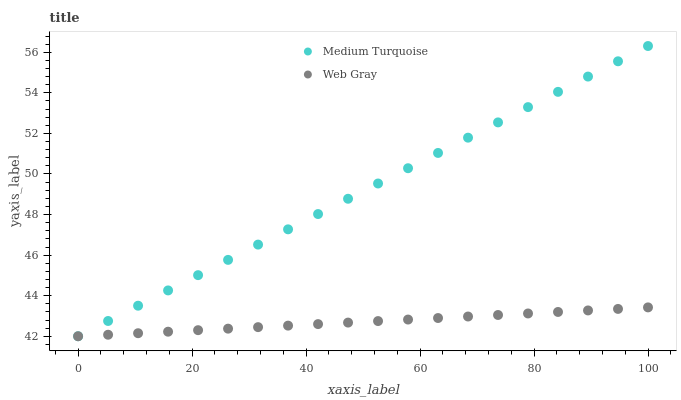Does Web Gray have the minimum area under the curve?
Answer yes or no. Yes. Does Medium Turquoise have the maximum area under the curve?
Answer yes or no. Yes. Does Medium Turquoise have the minimum area under the curve?
Answer yes or no. No. Is Web Gray the smoothest?
Answer yes or no. Yes. Is Medium Turquoise the roughest?
Answer yes or no. Yes. Is Medium Turquoise the smoothest?
Answer yes or no. No. Does Web Gray have the lowest value?
Answer yes or no. Yes. Does Medium Turquoise have the highest value?
Answer yes or no. Yes. Does Web Gray intersect Medium Turquoise?
Answer yes or no. Yes. Is Web Gray less than Medium Turquoise?
Answer yes or no. No. Is Web Gray greater than Medium Turquoise?
Answer yes or no. No. 